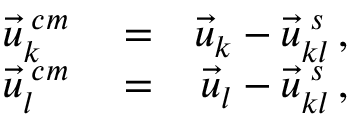<formula> <loc_0><loc_0><loc_500><loc_500>\begin{array} { r l r } { \vec { u } _ { k } ^ { \, c m } } & = } & { \vec { u } _ { k } - \vec { u } _ { k l } ^ { \, s } \, , } \\ { \vec { u } _ { l } ^ { \, c m } } & = } & { \vec { u } _ { l } - \vec { u } _ { k l } ^ { \, s } \, , } \end{array}</formula> 